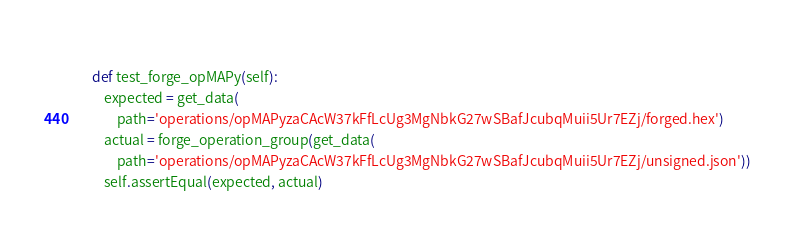Convert code to text. <code><loc_0><loc_0><loc_500><loc_500><_Python_>        
    def test_forge_opMAPy(self):
        expected = get_data(
            path='operations/opMAPyzaCAcW37kFfLcUg3MgNbkG27wSBafJcubqMuii5Ur7EZj/forged.hex')
        actual = forge_operation_group(get_data(
            path='operations/opMAPyzaCAcW37kFfLcUg3MgNbkG27wSBafJcubqMuii5Ur7EZj/unsigned.json'))
        self.assertEqual(expected, actual)
</code> 